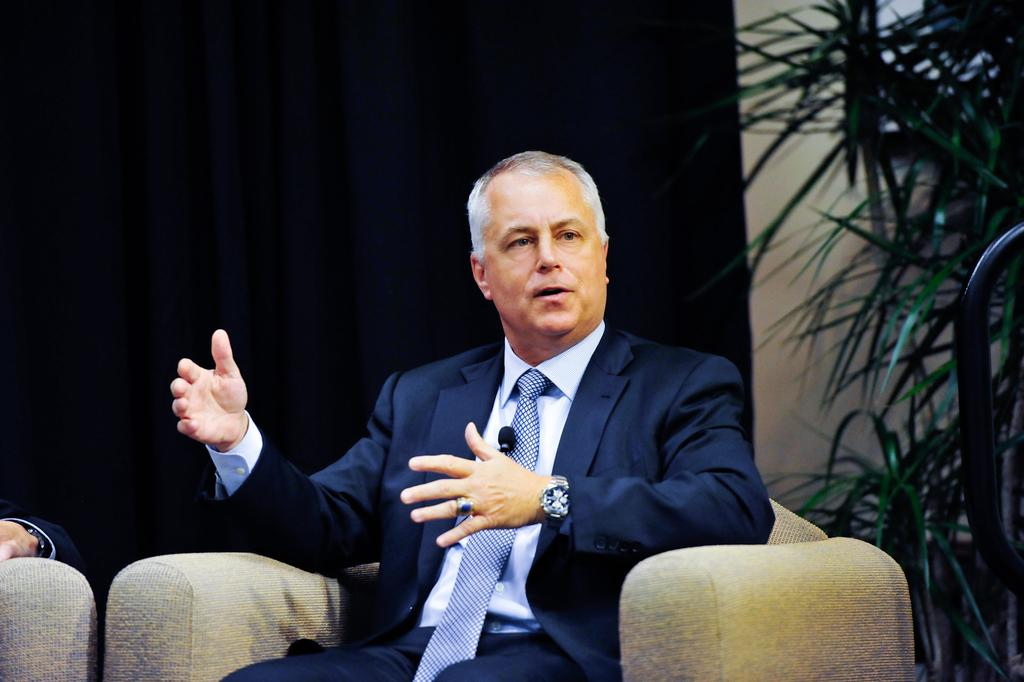What is the main subject of the image? There is a man in the image. What is the man doing in the image? The man is sitting on a chair. What type of clothing is the man wearing? The man is wearing a tie, a shirt, and a coat. What accessory is the man wearing on his wrist? The man is wearing a watch. What can be seen in the background of the image? There is a plant and other objects in the background of the image. What type of dinner is the man preparing in the image? There is no indication in the image that the man is preparing dinner, as he is sitting on a chair and not engaged in any cooking or food preparation activities. 